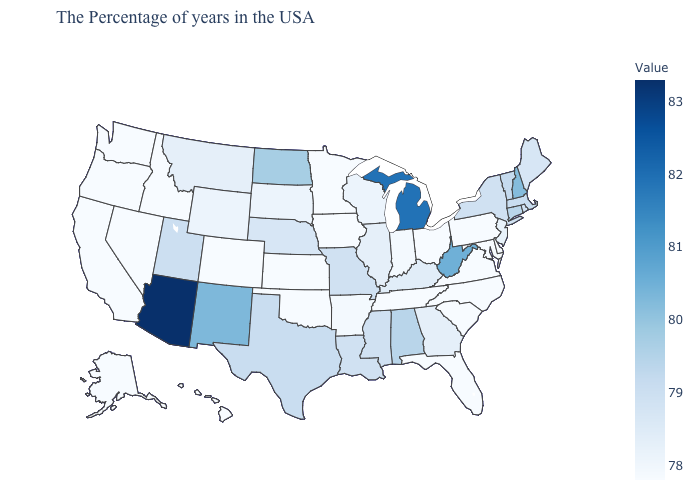Is the legend a continuous bar?
Give a very brief answer. Yes. Does Montana have the highest value in the West?
Write a very short answer. No. Which states have the lowest value in the USA?
Short answer required. Delaware, Maryland, Pennsylvania, Virginia, North Carolina, South Carolina, Ohio, Florida, Tennessee, Minnesota, Iowa, Kansas, Oklahoma, Colorado, Idaho, Nevada, California, Washington, Oregon, Alaska, Hawaii. Does North Carolina have the lowest value in the USA?
Quick response, please. Yes. Which states have the lowest value in the USA?
Give a very brief answer. Delaware, Maryland, Pennsylvania, Virginia, North Carolina, South Carolina, Ohio, Florida, Tennessee, Minnesota, Iowa, Kansas, Oklahoma, Colorado, Idaho, Nevada, California, Washington, Oregon, Alaska, Hawaii. Is the legend a continuous bar?
Short answer required. Yes. Does Nevada have the highest value in the USA?
Concise answer only. No. 